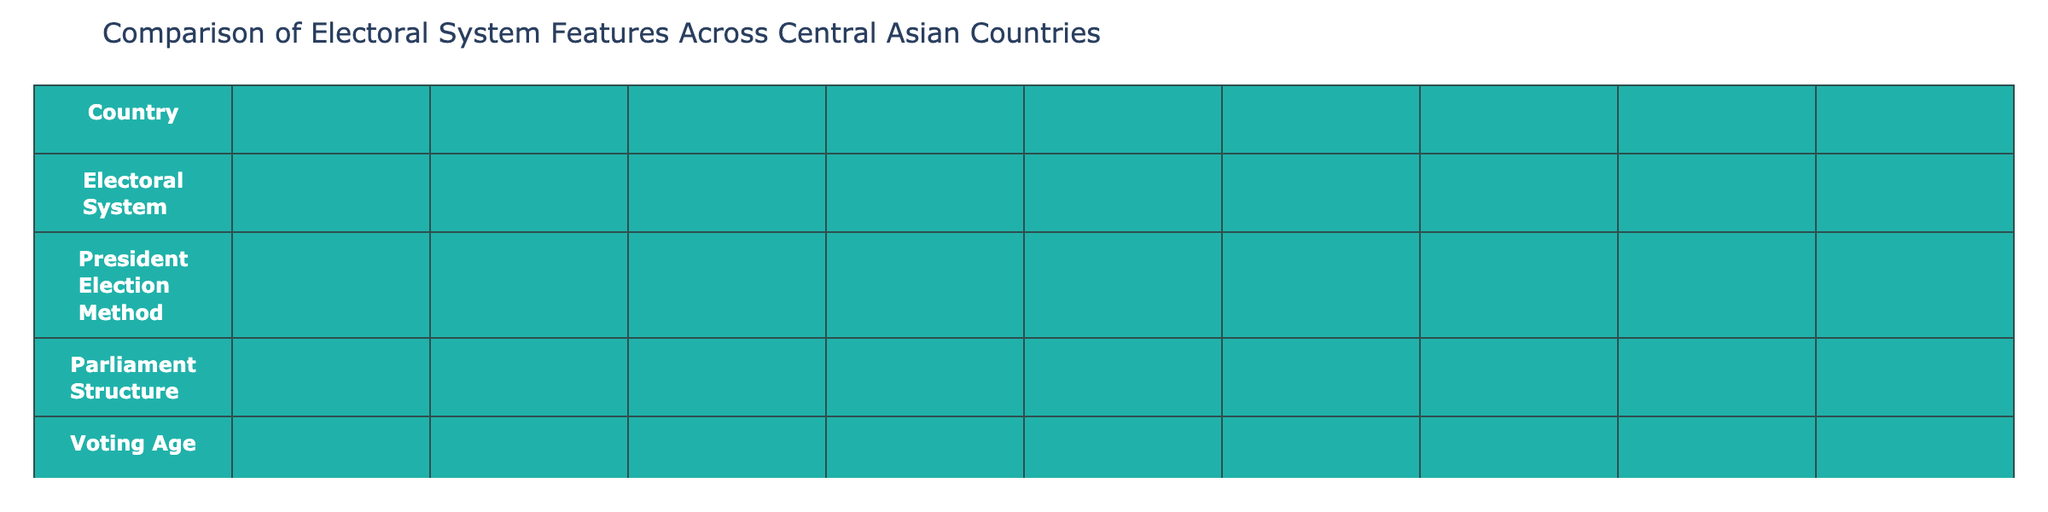What is the voting age across Central Asian countries in the table? All countries in the table have a voting age of 18, as indicated in the "Voting Age" row.
Answer: 18 Which countries have implemented e-voting? Only Turkmenistan and Uzbekistan are in the pilot phase for e-voting, while Kazakhstan, Kyrgyzstan, Tajikistan, and Uzbekistan have not fully implemented it.
Answer: Turkmenistan and Uzbekistan (pilot phase) How many countries have a bicameral parliament structure? The table lists two countries with a bicameral parliament structure: Kazakhstan and Uzbekistan.
Answer: 2 What is the election frequency for all the countries listed? All countries have an election frequency of 5 years as stated in the "Election Frequency (Years)" column.
Answer: 5 years Which country has a mixed electoral system and indirect presidential election method? Uzbekistan is the only country listed with a mixed electoral system and an indirect method for presidential elections.
Answer: Uzbekistan Do any countries have mandatory voting? No, the table indicates that none of the countries have mandatory voting as specified in the "Mandatory Voting" column.
Answer: No Which country has the highest level of proportional representation? Kyrgyzstan features full proportional representation, whereas Kazakhstan and Tajikistan have partial. Turkmenistan and Uzbekistan have no proportional representation.
Answer: Kyrgyzstan Is there a country in the table where the electoral commission is not independent? All countries in the table have an independent electoral commission as per the "Independent Electoral Commission" column.
Answer: No Which country's parliament structure is unique among the four listed? Turkmenistan has a unicameral parliament structure, while the others have bicameral or mixed structures.
Answer: Turkmenistan If we sum the countries that utilize proportional representation, how many do we find? Kyrgyzstan has full representation, and both Kazakhstan and Tajikistan have partial representation, leading to a total of 3 countries utilizing some form of proportional representation.
Answer: 3 